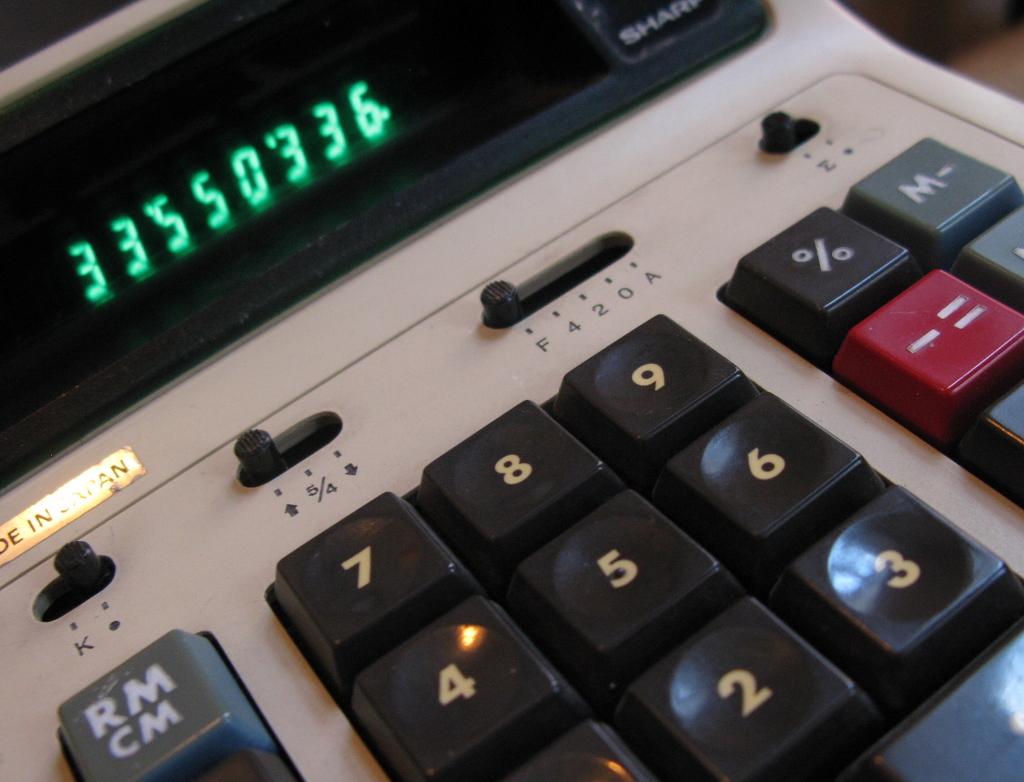What is displayed on the calculator screen?
Ensure brevity in your answer.  33550336. What is the furthest left key?
Provide a short and direct response. Rm cm. 